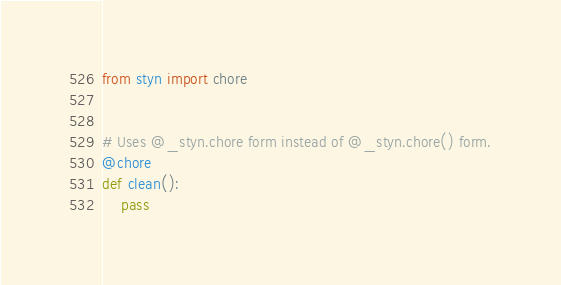<code> <loc_0><loc_0><loc_500><loc_500><_Python_>from styn import chore


# Uses @_styn.chore form instead of @_styn.chore() form.
@chore
def clean():
    pass
</code> 